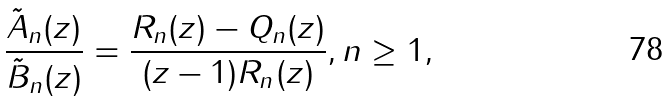Convert formula to latex. <formula><loc_0><loc_0><loc_500><loc_500>\frac { \tilde { A } _ { n } ( z ) } { \tilde { B } _ { n } ( z ) } = \frac { R _ { n } ( z ) - Q _ { n } ( z ) } { ( z - 1 ) R _ { n } ( z ) } , n \geq 1 ,</formula> 